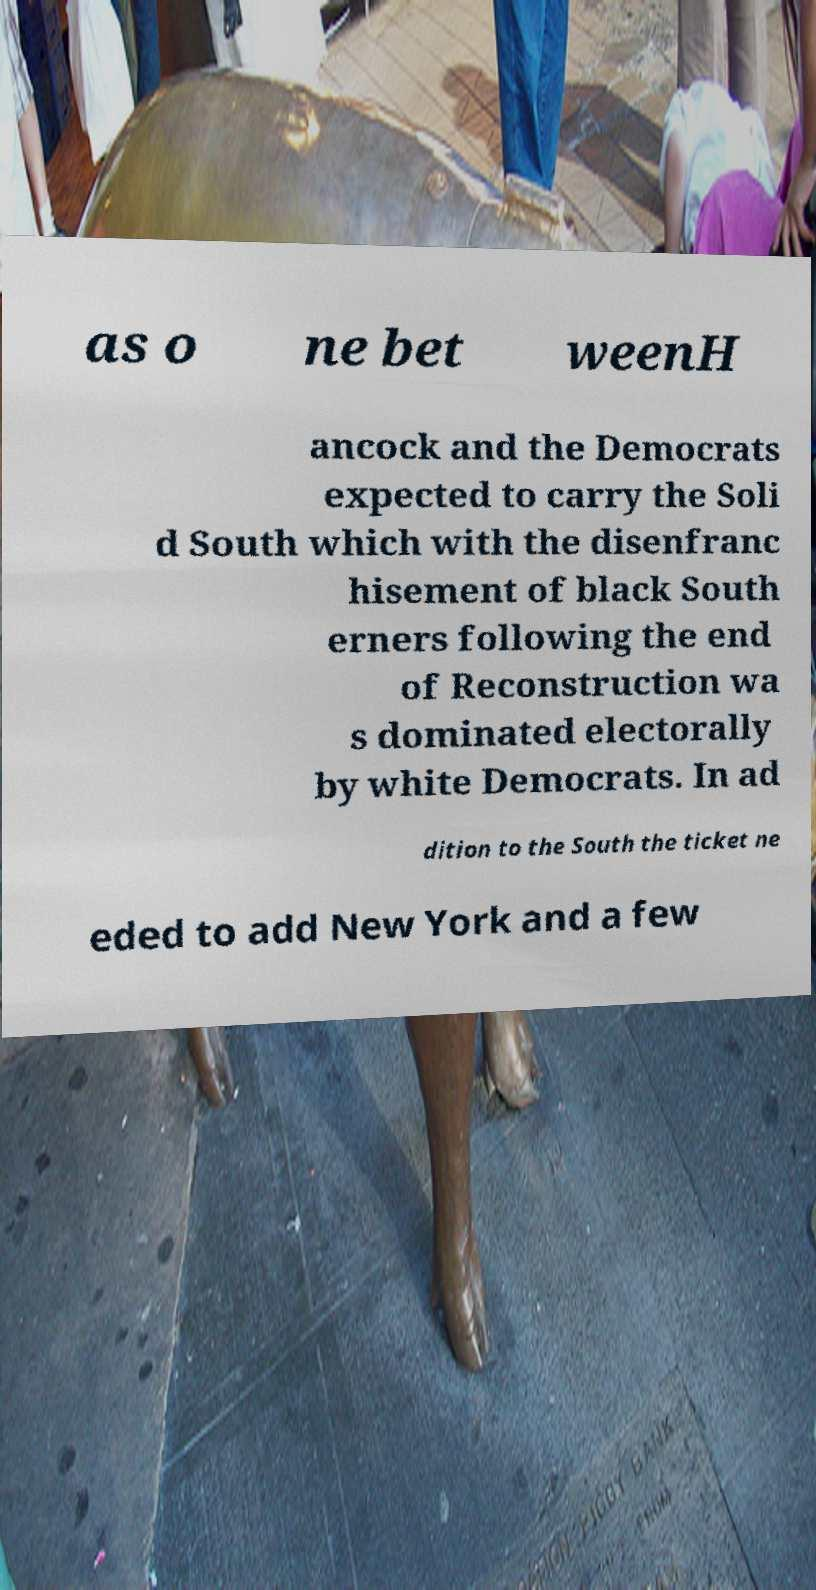There's text embedded in this image that I need extracted. Can you transcribe it verbatim? as o ne bet weenH ancock and the Democrats expected to carry the Soli d South which with the disenfranc hisement of black South erners following the end of Reconstruction wa s dominated electorally by white Democrats. In ad dition to the South the ticket ne eded to add New York and a few 